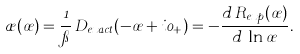<formula> <loc_0><loc_0><loc_500><loc_500>\rho ( \sigma ) = \frac { 1 } { \pi } \, D _ { e x a c t } ( - \sigma + i 0 _ { + } ) = - \frac { d \, R _ { e x p } ( \sigma ) } { d \, \ln \sigma } .</formula> 